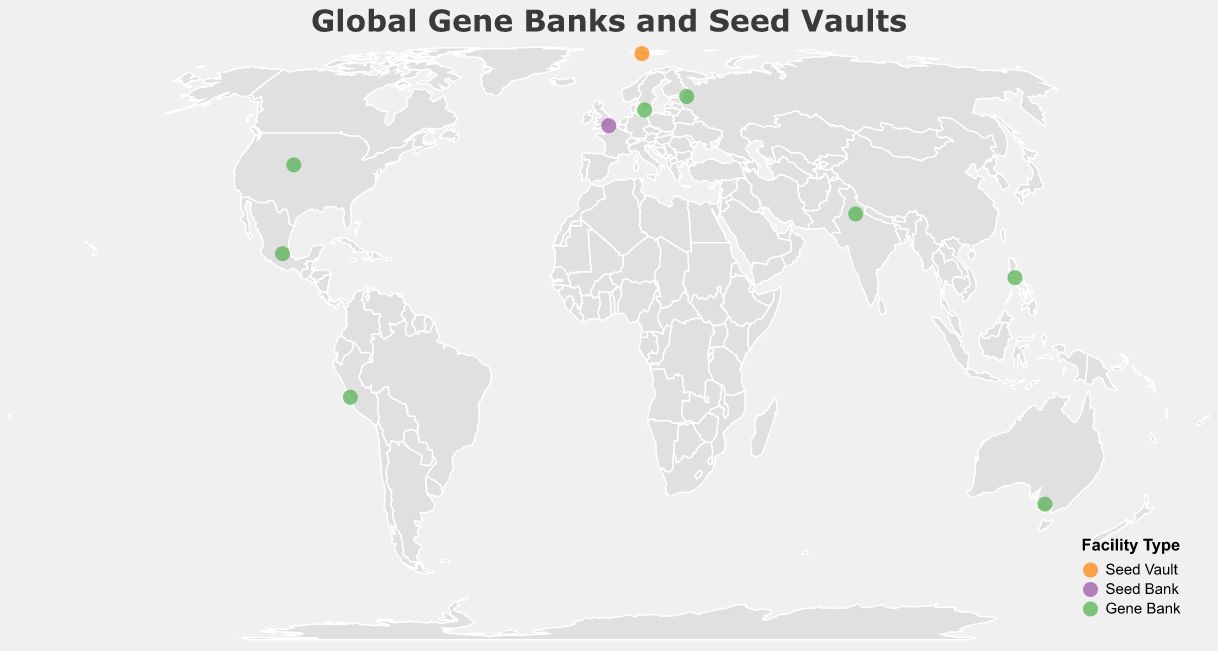What type of gene bank is located near the equator? The International Rice Gene Bank, specializing in rice varieties, is located at a latitude of 14.1652, which is close to the equator.
Answer: Gene Bank Which facility is located furthest north? The Svalbard Global Seed Vault is at a latitude of 78.2386, making it the northernmost facility on the map.
Answer: Svalbard Global Seed Vault How many gene banks are located in the Southern Hemisphere? The two gene banks in the Southern Hemisphere are the Australian Grains Genebank (-36.7570 latitude) and the International Potato Center (-12.0766 latitude).
Answer: 2 Which facility has the specialty of wild plant species? The Millennium Seed Bank, located at a latitude of 51.0657 and longitude of -0.0873, specializes in wild plant species.
Answer: Millennium Seed Bank Compare the number of gene banks and seed banks on the map. Which type is more common? There are more gene banks (8) compared to seed banks (1) and seed vaults (1), showing gene banks are more prevalent on the map.
Answer: Gene Banks What is the specialty of the facility located in Mexico? The International Maize and Wheat Improvement Center, located at 19.5321 latitude and -98.8462 longitude, specializes in maize and wheat.
Answer: Maize and Wheat What is the most common specialty among the facilities? The gene banks specializing in crop diversity and specific crops like rice, maize, wheat, and potatoes are the most common specialties, indicating a focus on a wide range of crops.
Answer: Diverse Crops and Specific Crops Which facility is the southernmost on the map? The Australian Grains Genebank, located at a latitude of -36.7570, is the southernmost facility depicted.
Answer: Australian Grains Genebank Name the gene bank dedicated to preserving Nordic crops. The Nordic Genetic Resource Center is located at 55.6761 latitude and 13.3417 longitude and focuses on Nordic crops.
Answer: Nordic Genetic Resource Center Compare and contrast the locations of the Svalbard Global Seed Vault and the National Bureau of Plant Genetic Resources. The Svalbard Global Seed Vault is located far north at 78.2386 latitude, while the National Bureau of Plant Genetic Resources is situated much further south at 28.6409 latitude. This demonstrates a broad geographic spread of gene conservation facilities.
Answer: Different latitudes, broad geographic spread 